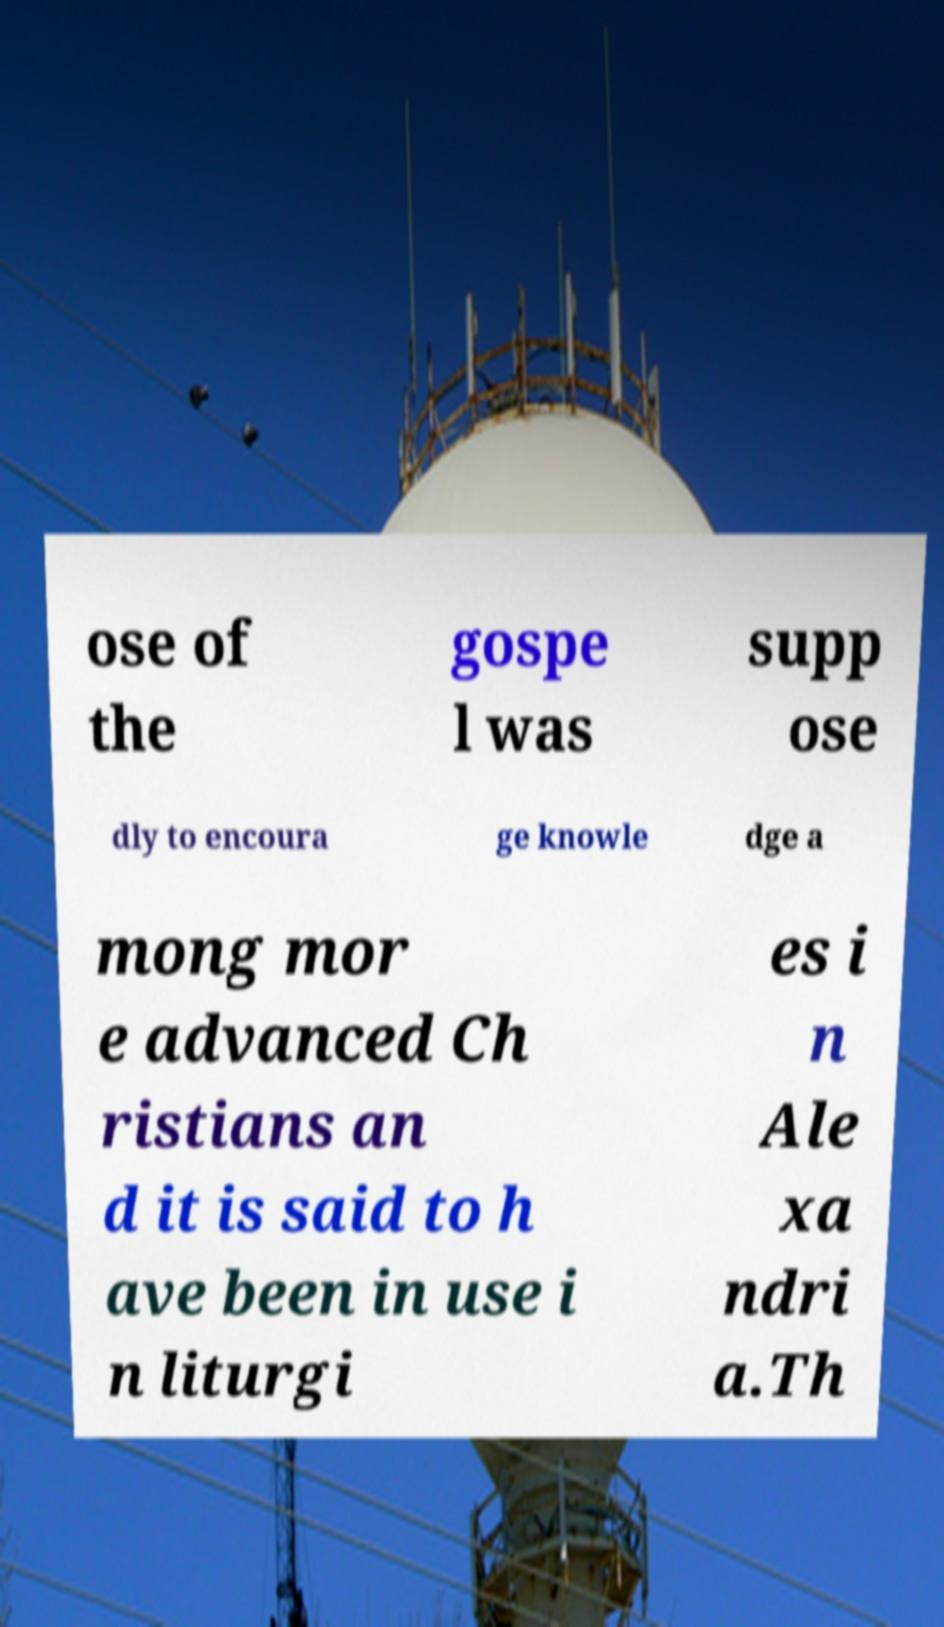What messages or text are displayed in this image? I need them in a readable, typed format. ose of the gospe l was supp ose dly to encoura ge knowle dge a mong mor e advanced Ch ristians an d it is said to h ave been in use i n liturgi es i n Ale xa ndri a.Th 